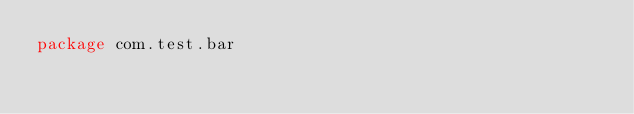Convert code to text. <code><loc_0><loc_0><loc_500><loc_500><_Kotlin_>package com.test.bar
</code> 